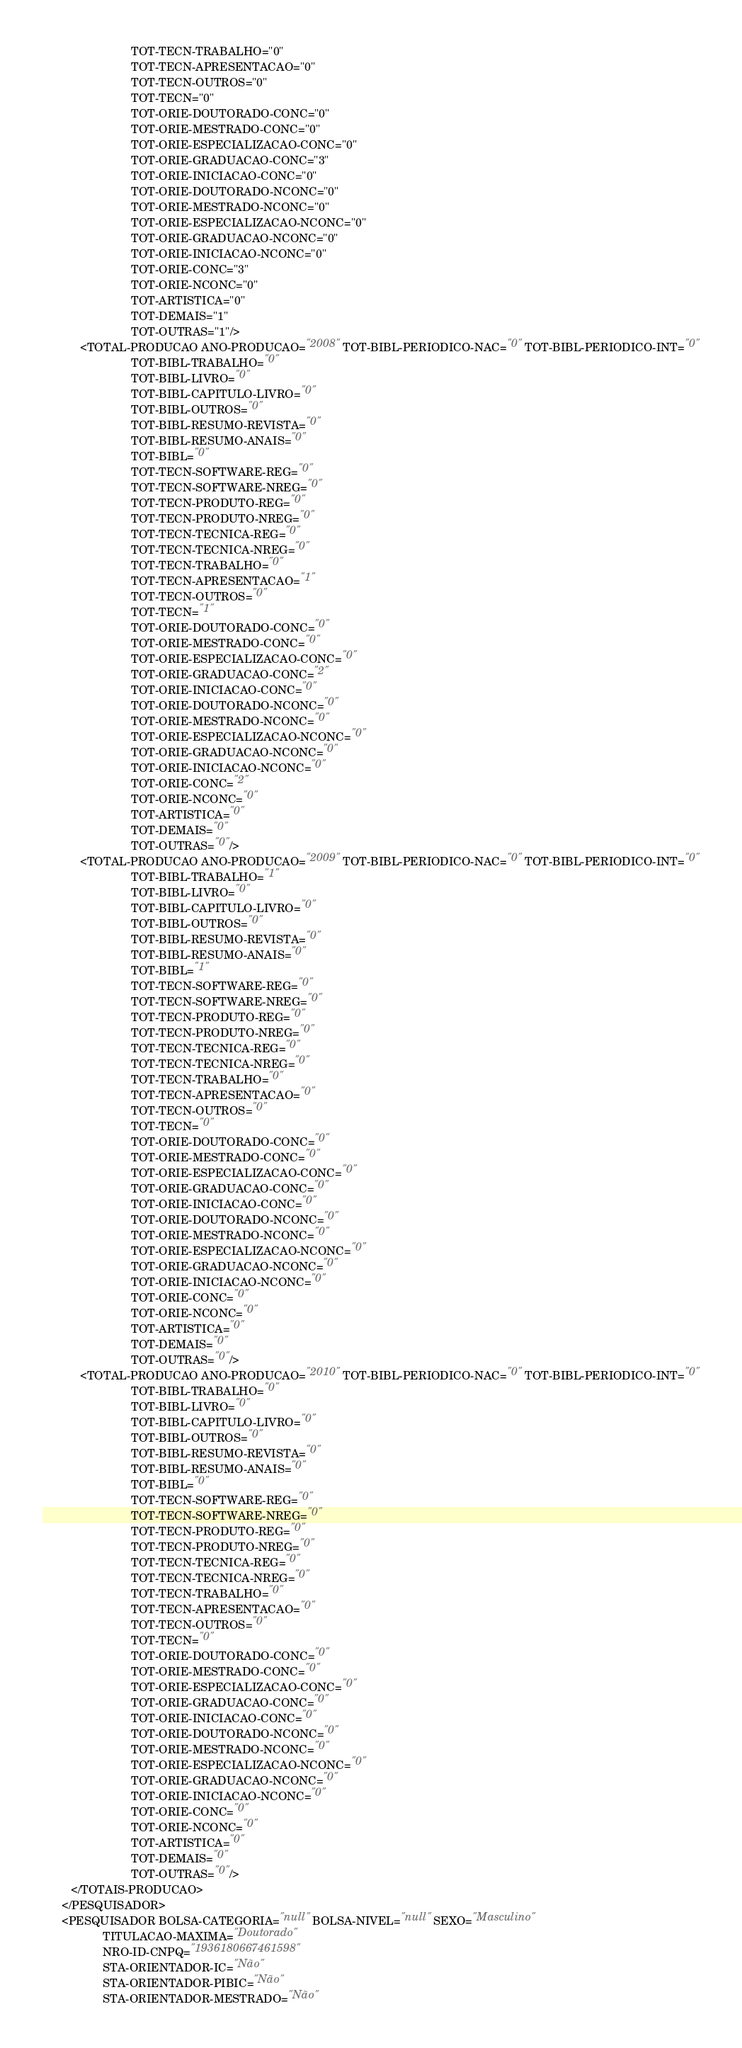<code> <loc_0><loc_0><loc_500><loc_500><_XML_>                            TOT-TECN-TRABALHO="0"
                            TOT-TECN-APRESENTACAO="0"
                            TOT-TECN-OUTROS="0"
                            TOT-TECN="0"
                            TOT-ORIE-DOUTORADO-CONC="0"
                            TOT-ORIE-MESTRADO-CONC="0"
                            TOT-ORIE-ESPECIALIZACAO-CONC="0"
                            TOT-ORIE-GRADUACAO-CONC="3"
                            TOT-ORIE-INICIACAO-CONC="0"
                            TOT-ORIE-DOUTORADO-NCONC="0"
                            TOT-ORIE-MESTRADO-NCONC="0"
                            TOT-ORIE-ESPECIALIZACAO-NCONC="0"
                            TOT-ORIE-GRADUACAO-NCONC="0"
                            TOT-ORIE-INICIACAO-NCONC="0"
                            TOT-ORIE-CONC="3"
                            TOT-ORIE-NCONC="0"
                            TOT-ARTISTICA="0"
                            TOT-DEMAIS="1"
                            TOT-OUTRAS="1"/>
            <TOTAL-PRODUCAO ANO-PRODUCAO="2008" TOT-BIBL-PERIODICO-NAC="0" TOT-BIBL-PERIODICO-INT="0"
                            TOT-BIBL-TRABALHO="0"
                            TOT-BIBL-LIVRO="0"
                            TOT-BIBL-CAPITULO-LIVRO="0"
                            TOT-BIBL-OUTROS="0"
                            TOT-BIBL-RESUMO-REVISTA="0"
                            TOT-BIBL-RESUMO-ANAIS="0"
                            TOT-BIBL="0"
                            TOT-TECN-SOFTWARE-REG="0"
                            TOT-TECN-SOFTWARE-NREG="0"
                            TOT-TECN-PRODUTO-REG="0"
                            TOT-TECN-PRODUTO-NREG="0"
                            TOT-TECN-TECNICA-REG="0"
                            TOT-TECN-TECNICA-NREG="0"
                            TOT-TECN-TRABALHO="0"
                            TOT-TECN-APRESENTACAO="1"
                            TOT-TECN-OUTROS="0"
                            TOT-TECN="1"
                            TOT-ORIE-DOUTORADO-CONC="0"
                            TOT-ORIE-MESTRADO-CONC="0"
                            TOT-ORIE-ESPECIALIZACAO-CONC="0"
                            TOT-ORIE-GRADUACAO-CONC="2"
                            TOT-ORIE-INICIACAO-CONC="0"
                            TOT-ORIE-DOUTORADO-NCONC="0"
                            TOT-ORIE-MESTRADO-NCONC="0"
                            TOT-ORIE-ESPECIALIZACAO-NCONC="0"
                            TOT-ORIE-GRADUACAO-NCONC="0"
                            TOT-ORIE-INICIACAO-NCONC="0"
                            TOT-ORIE-CONC="2"
                            TOT-ORIE-NCONC="0"
                            TOT-ARTISTICA="0"
                            TOT-DEMAIS="0"
                            TOT-OUTRAS="0"/>
            <TOTAL-PRODUCAO ANO-PRODUCAO="2009" TOT-BIBL-PERIODICO-NAC="0" TOT-BIBL-PERIODICO-INT="0"
                            TOT-BIBL-TRABALHO="1"
                            TOT-BIBL-LIVRO="0"
                            TOT-BIBL-CAPITULO-LIVRO="0"
                            TOT-BIBL-OUTROS="0"
                            TOT-BIBL-RESUMO-REVISTA="0"
                            TOT-BIBL-RESUMO-ANAIS="0"
                            TOT-BIBL="1"
                            TOT-TECN-SOFTWARE-REG="0"
                            TOT-TECN-SOFTWARE-NREG="0"
                            TOT-TECN-PRODUTO-REG="0"
                            TOT-TECN-PRODUTO-NREG="0"
                            TOT-TECN-TECNICA-REG="0"
                            TOT-TECN-TECNICA-NREG="0"
                            TOT-TECN-TRABALHO="0"
                            TOT-TECN-APRESENTACAO="0"
                            TOT-TECN-OUTROS="0"
                            TOT-TECN="0"
                            TOT-ORIE-DOUTORADO-CONC="0"
                            TOT-ORIE-MESTRADO-CONC="0"
                            TOT-ORIE-ESPECIALIZACAO-CONC="0"
                            TOT-ORIE-GRADUACAO-CONC="0"
                            TOT-ORIE-INICIACAO-CONC="0"
                            TOT-ORIE-DOUTORADO-NCONC="0"
                            TOT-ORIE-MESTRADO-NCONC="0"
                            TOT-ORIE-ESPECIALIZACAO-NCONC="0"
                            TOT-ORIE-GRADUACAO-NCONC="0"
                            TOT-ORIE-INICIACAO-NCONC="0"
                            TOT-ORIE-CONC="0"
                            TOT-ORIE-NCONC="0"
                            TOT-ARTISTICA="0"
                            TOT-DEMAIS="0"
                            TOT-OUTRAS="0"/>
            <TOTAL-PRODUCAO ANO-PRODUCAO="2010" TOT-BIBL-PERIODICO-NAC="0" TOT-BIBL-PERIODICO-INT="0"
                            TOT-BIBL-TRABALHO="0"
                            TOT-BIBL-LIVRO="0"
                            TOT-BIBL-CAPITULO-LIVRO="0"
                            TOT-BIBL-OUTROS="0"
                            TOT-BIBL-RESUMO-REVISTA="0"
                            TOT-BIBL-RESUMO-ANAIS="0"
                            TOT-BIBL="0"
                            TOT-TECN-SOFTWARE-REG="0"
                            TOT-TECN-SOFTWARE-NREG="0"
                            TOT-TECN-PRODUTO-REG="0"
                            TOT-TECN-PRODUTO-NREG="0"
                            TOT-TECN-TECNICA-REG="0"
                            TOT-TECN-TECNICA-NREG="0"
                            TOT-TECN-TRABALHO="0"
                            TOT-TECN-APRESENTACAO="0"
                            TOT-TECN-OUTROS="0"
                            TOT-TECN="0"
                            TOT-ORIE-DOUTORADO-CONC="0"
                            TOT-ORIE-MESTRADO-CONC="0"
                            TOT-ORIE-ESPECIALIZACAO-CONC="0"
                            TOT-ORIE-GRADUACAO-CONC="0"
                            TOT-ORIE-INICIACAO-CONC="0"
                            TOT-ORIE-DOUTORADO-NCONC="0"
                            TOT-ORIE-MESTRADO-NCONC="0"
                            TOT-ORIE-ESPECIALIZACAO-NCONC="0"
                            TOT-ORIE-GRADUACAO-NCONC="0"
                            TOT-ORIE-INICIACAO-NCONC="0"
                            TOT-ORIE-CONC="0"
                            TOT-ORIE-NCONC="0"
                            TOT-ARTISTICA="0"
                            TOT-DEMAIS="0"
                            TOT-OUTRAS="0"/>
         </TOTAIS-PRODUCAO>
      </PESQUISADOR>
      <PESQUISADOR BOLSA-CATEGORIA="null" BOLSA-NIVEL="null" SEXO="Masculino"
                   TITULACAO-MAXIMA="Doutorado"
                   NRO-ID-CNPQ="1936180667461598"
                   STA-ORIENTADOR-IC="Não"
                   STA-ORIENTADOR-PIBIC="Não"
                   STA-ORIENTADOR-MESTRADO="Não"</code> 